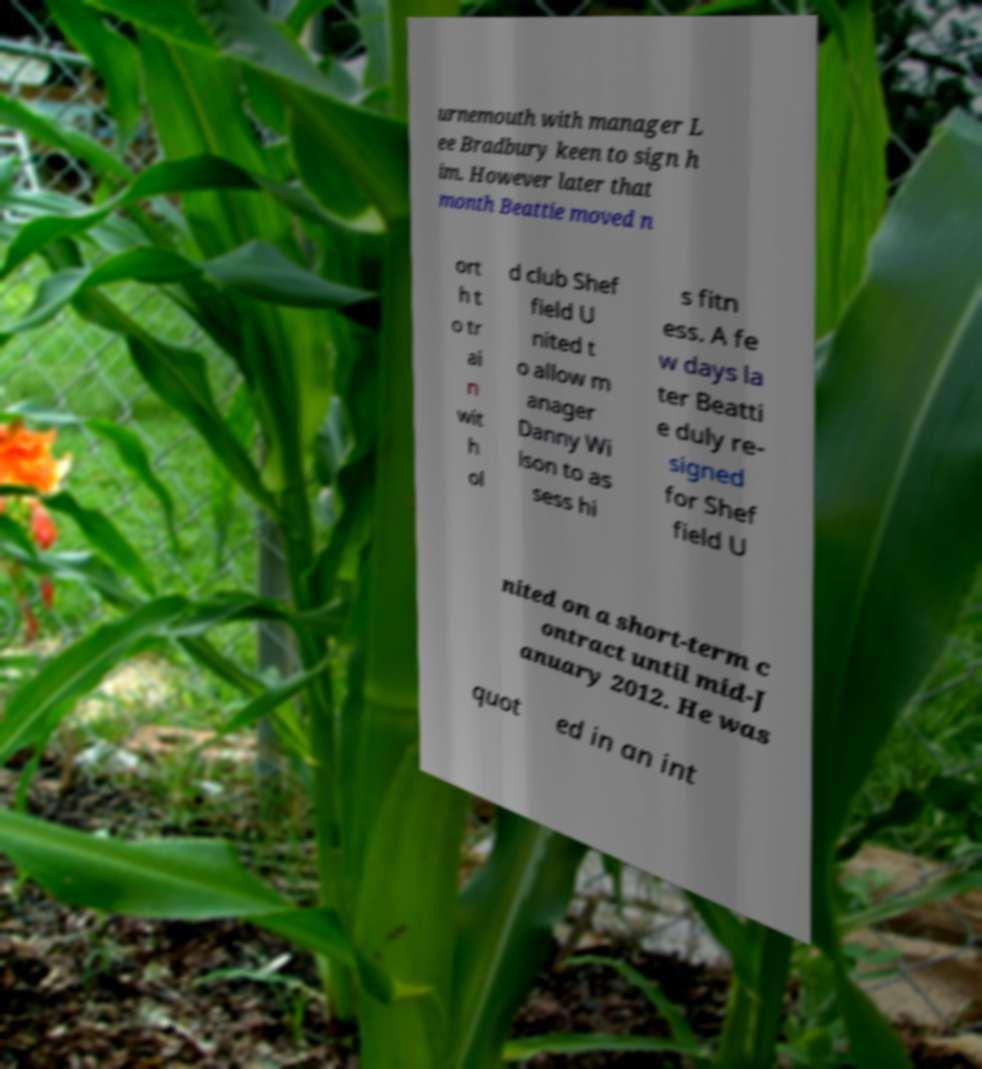Please read and relay the text visible in this image. What does it say? urnemouth with manager L ee Bradbury keen to sign h im. However later that month Beattie moved n ort h t o tr ai n wit h ol d club Shef field U nited t o allow m anager Danny Wi lson to as sess hi s fitn ess. A fe w days la ter Beatti e duly re- signed for Shef field U nited on a short-term c ontract until mid-J anuary 2012. He was quot ed in an int 